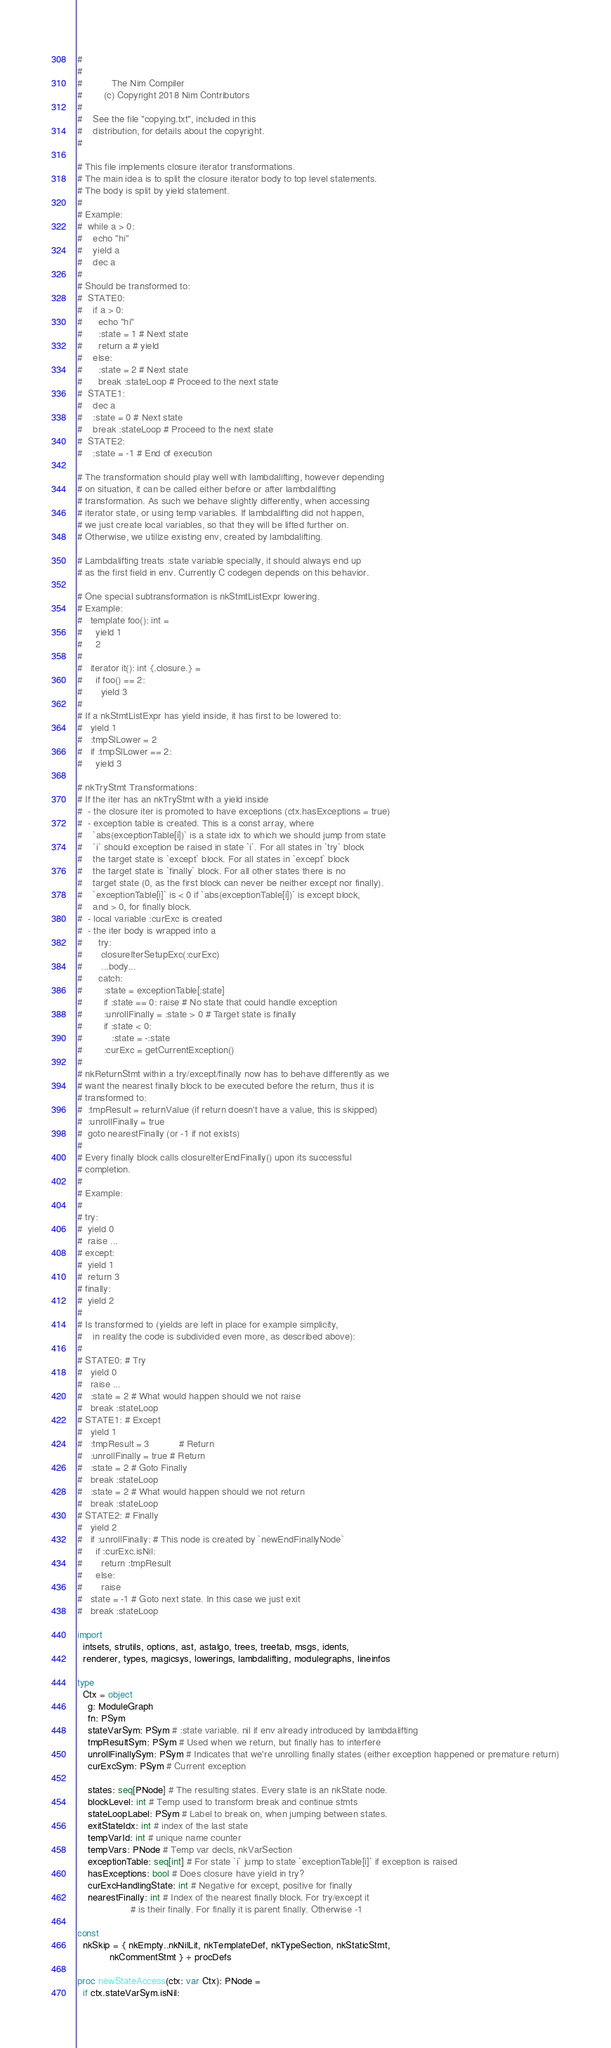<code> <loc_0><loc_0><loc_500><loc_500><_Nim_>#
#
#           The Nim Compiler
#        (c) Copyright 2018 Nim Contributors
#
#    See the file "copying.txt", included in this
#    distribution, for details about the copyright.
#

# This file implements closure iterator transformations.
# The main idea is to split the closure iterator body to top level statements.
# The body is split by yield statement.
#
# Example:
#  while a > 0:
#    echo "hi"
#    yield a
#    dec a
#
# Should be transformed to:
#  STATE0:
#    if a > 0:
#      echo "hi"
#      :state = 1 # Next state
#      return a # yield
#    else:
#      :state = 2 # Next state
#      break :stateLoop # Proceed to the next state
#  STATE1:
#    dec a
#    :state = 0 # Next state
#    break :stateLoop # Proceed to the next state
#  STATE2:
#    :state = -1 # End of execution

# The transformation should play well with lambdalifting, however depending
# on situation, it can be called either before or after lambdalifting
# transformation. As such we behave slightly differently, when accessing
# iterator state, or using temp variables. If lambdalifting did not happen,
# we just create local variables, so that they will be lifted further on.
# Otherwise, we utilize existing env, created by lambdalifting.

# Lambdalifting treats :state variable specially, it should always end up
# as the first field in env. Currently C codegen depends on this behavior.

# One special subtransformation is nkStmtListExpr lowering.
# Example:
#   template foo(): int =
#     yield 1
#     2
#
#   iterator it(): int {.closure.} =
#     if foo() == 2:
#       yield 3
#
# If a nkStmtListExpr has yield inside, it has first to be lowered to:
#   yield 1
#   :tmpSlLower = 2
#   if :tmpSlLower == 2:
#     yield 3

# nkTryStmt Transformations:
# If the iter has an nkTryStmt with a yield inside
#  - the closure iter is promoted to have exceptions (ctx.hasExceptions = true)
#  - exception table is created. This is a const array, where
#    `abs(exceptionTable[i])` is a state idx to which we should jump from state
#    `i` should exception be raised in state `i`. For all states in `try` block
#    the target state is `except` block. For all states in `except` block
#    the target state is `finally` block. For all other states there is no
#    target state (0, as the first block can never be neither except nor finally).
#    `exceptionTable[i]` is < 0 if `abs(exceptionTable[i])` is except block,
#    and > 0, for finally block.
#  - local variable :curExc is created
#  - the iter body is wrapped into a
#      try:
#       closureIterSetupExc(:curExc)
#       ...body...
#      catch:
#        :state = exceptionTable[:state]
#        if :state == 0: raise # No state that could handle exception
#        :unrollFinally = :state > 0 # Target state is finally
#        if :state < 0:
#           :state = -:state
#        :curExc = getCurrentException()
#
# nkReturnStmt within a try/except/finally now has to behave differently as we
# want the nearest finally block to be executed before the return, thus it is
# transformed to:
#  :tmpResult = returnValue (if return doesn't have a value, this is skipped)
#  :unrollFinally = true
#  goto nearestFinally (or -1 if not exists)
#
# Every finally block calls closureIterEndFinally() upon its successful
# completion.
#
# Example:
#
# try:
#  yield 0
#  raise ...
# except:
#  yield 1
#  return 3
# finally:
#  yield 2
#
# Is transformed to (yields are left in place for example simplicity,
#    in reality the code is subdivided even more, as described above):
#
# STATE0: # Try
#   yield 0
#   raise ...
#   :state = 2 # What would happen should we not raise
#   break :stateLoop
# STATE1: # Except
#   yield 1
#   :tmpResult = 3           # Return
#   :unrollFinally = true # Return
#   :state = 2 # Goto Finally
#   break :stateLoop
#   :state = 2 # What would happen should we not return
#   break :stateLoop
# STATE2: # Finally
#   yield 2
#   if :unrollFinally: # This node is created by `newEndFinallyNode`
#     if :curExc.isNil:
#       return :tmpResult
#     else:
#       raise
#   state = -1 # Goto next state. In this case we just exit
#   break :stateLoop

import
  intsets, strutils, options, ast, astalgo, trees, treetab, msgs, idents,
  renderer, types, magicsys, lowerings, lambdalifting, modulegraphs, lineinfos

type
  Ctx = object
    g: ModuleGraph
    fn: PSym
    stateVarSym: PSym # :state variable. nil if env already introduced by lambdalifting
    tmpResultSym: PSym # Used when we return, but finally has to interfere
    unrollFinallySym: PSym # Indicates that we're unrolling finally states (either exception happened or premature return)
    curExcSym: PSym # Current exception

    states: seq[PNode] # The resulting states. Every state is an nkState node.
    blockLevel: int # Temp used to transform break and continue stmts
    stateLoopLabel: PSym # Label to break on, when jumping between states.
    exitStateIdx: int # index of the last state
    tempVarId: int # unique name counter
    tempVars: PNode # Temp var decls, nkVarSection
    exceptionTable: seq[int] # For state `i` jump to state `exceptionTable[i]` if exception is raised
    hasExceptions: bool # Does closure have yield in try?
    curExcHandlingState: int # Negative for except, positive for finally
    nearestFinally: int # Index of the nearest finally block. For try/except it
                    # is their finally. For finally it is parent finally. Otherwise -1

const
  nkSkip = { nkEmpty..nkNilLit, nkTemplateDef, nkTypeSection, nkStaticStmt,
            nkCommentStmt } + procDefs

proc newStateAccess(ctx: var Ctx): PNode =
  if ctx.stateVarSym.isNil:</code> 